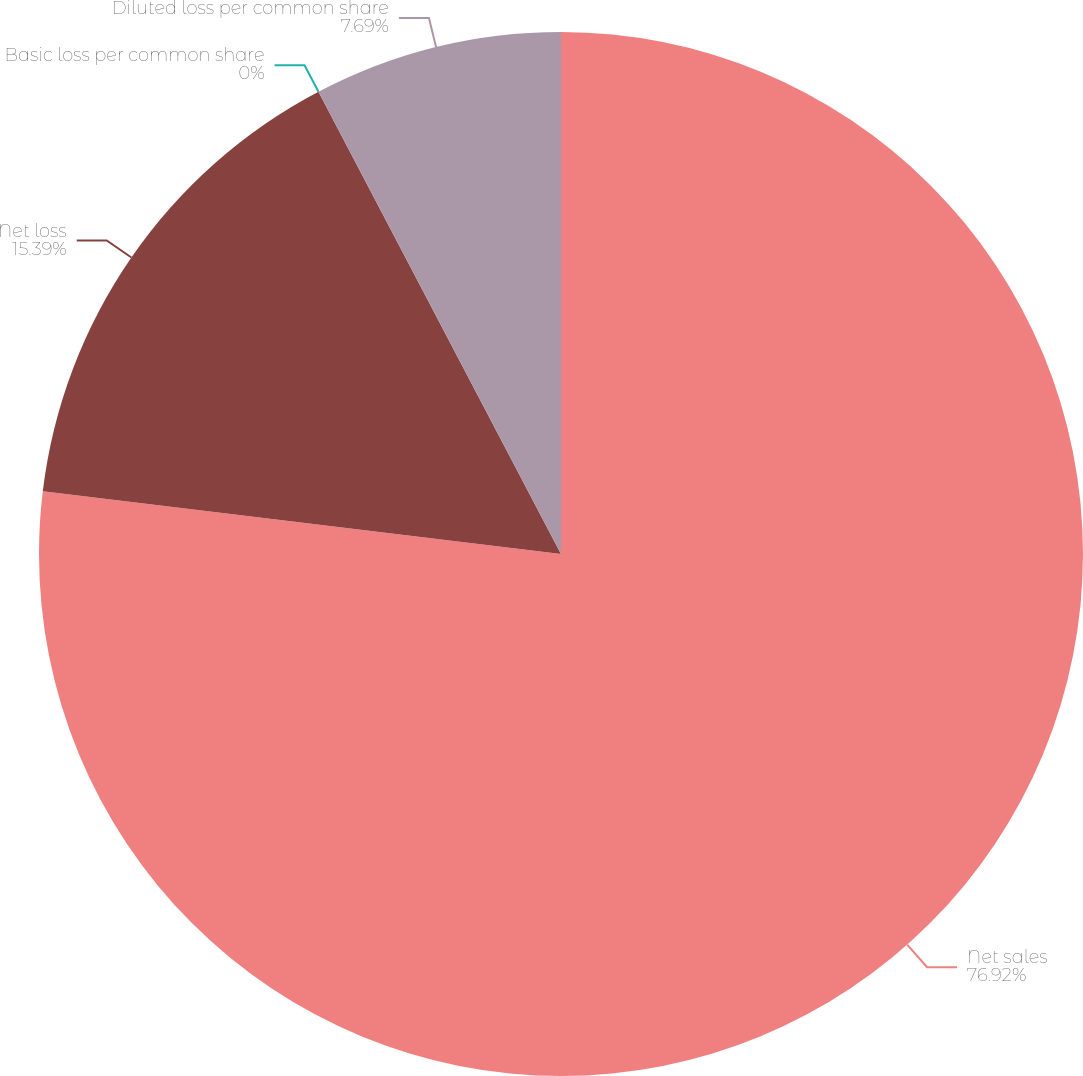<chart> <loc_0><loc_0><loc_500><loc_500><pie_chart><fcel>Net sales<fcel>Net loss<fcel>Basic loss per common share<fcel>Diluted loss per common share<nl><fcel>76.92%<fcel>15.39%<fcel>0.0%<fcel>7.69%<nl></chart> 